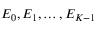Convert formula to latex. <formula><loc_0><loc_0><loc_500><loc_500>E _ { 0 } , E _ { 1 } , \dots , E _ { K - 1 }</formula> 